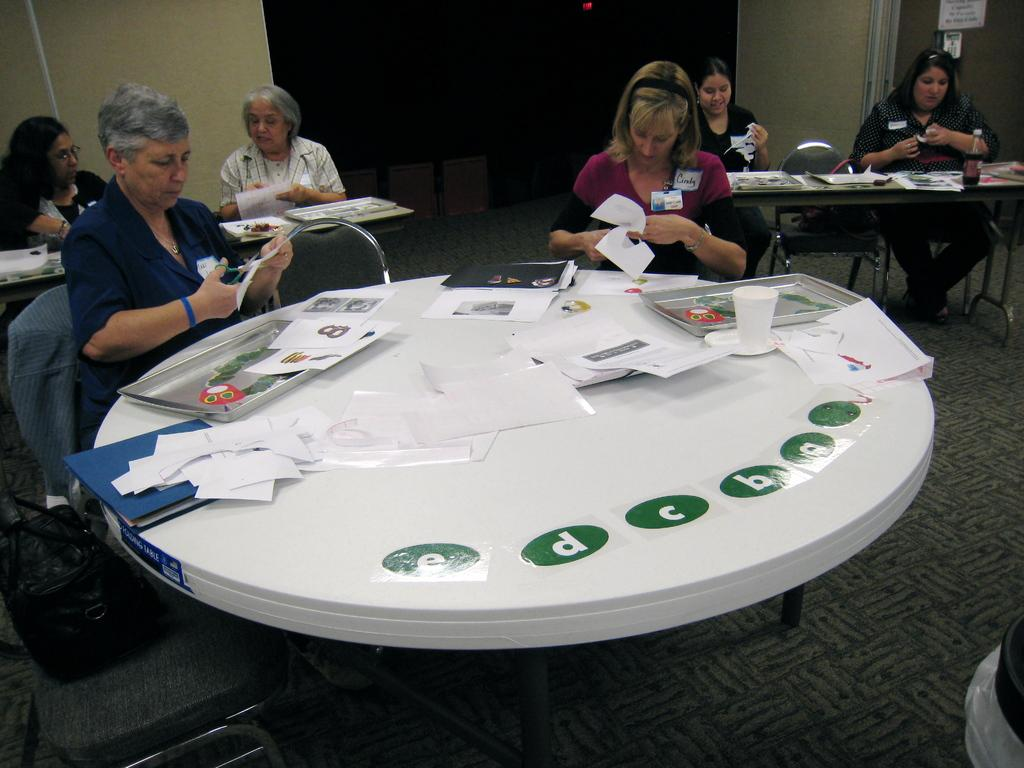What is happening in the image? There is a group of people in the image. How are the people positioned in the image? The people are seated on chairs. What objects are on the table in the image? There are papers and glasses on the table. What type of garden can be seen in the image? There is no garden present in the image. How many toes are visible in the image? There is no reference to toes or feet in the image, so it is not possible to determine how many toes might be visible. 